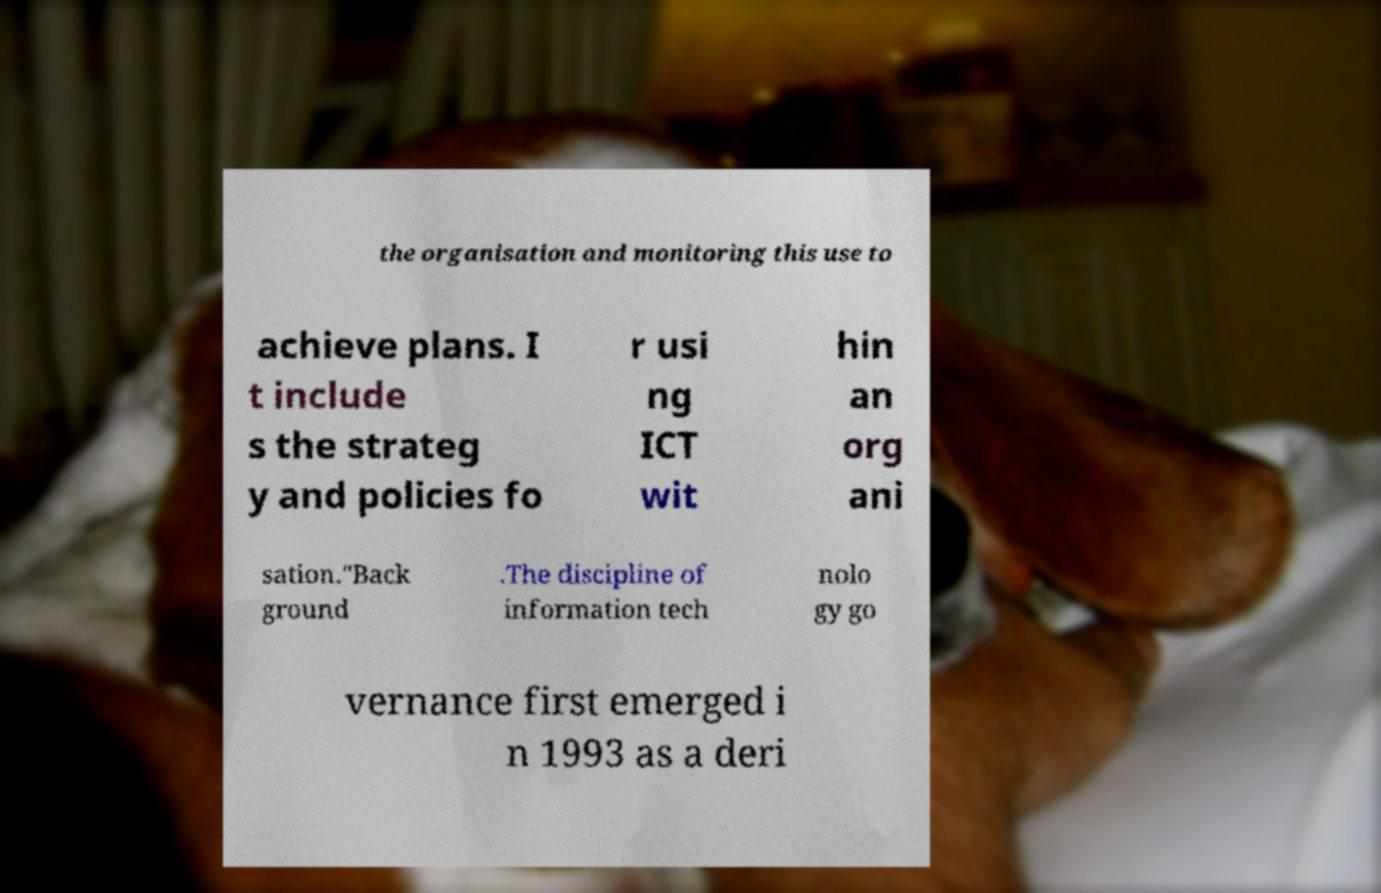Could you extract and type out the text from this image? the organisation and monitoring this use to achieve plans. I t include s the strateg y and policies fo r usi ng ICT wit hin an org ani sation."Back ground .The discipline of information tech nolo gy go vernance first emerged i n 1993 as a deri 